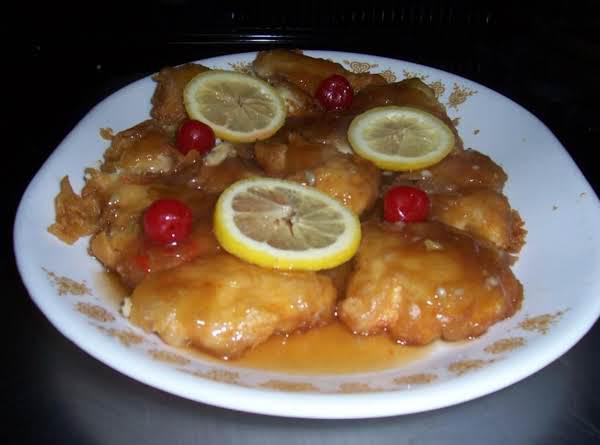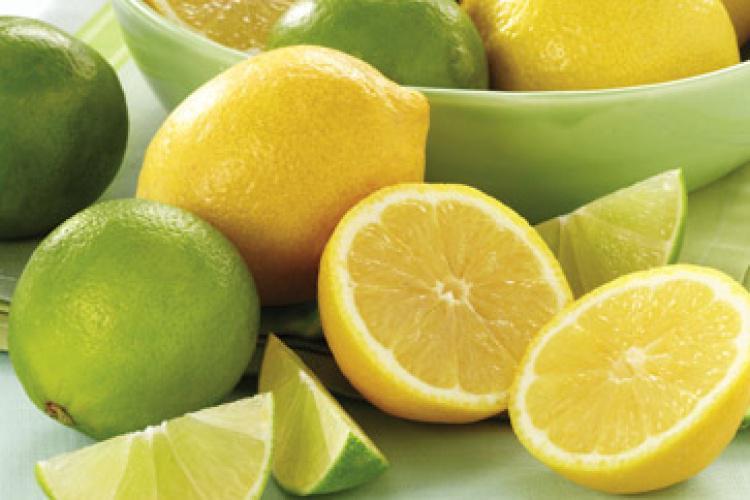The first image is the image on the left, the second image is the image on the right. For the images shown, is this caption "There is a whole lemon in exactly one of the images." true? Answer yes or no. Yes. The first image is the image on the left, the second image is the image on the right. For the images displayed, is the sentence "The lemon slices are on top of meat in at least one of the images." factually correct? Answer yes or no. Yes. 